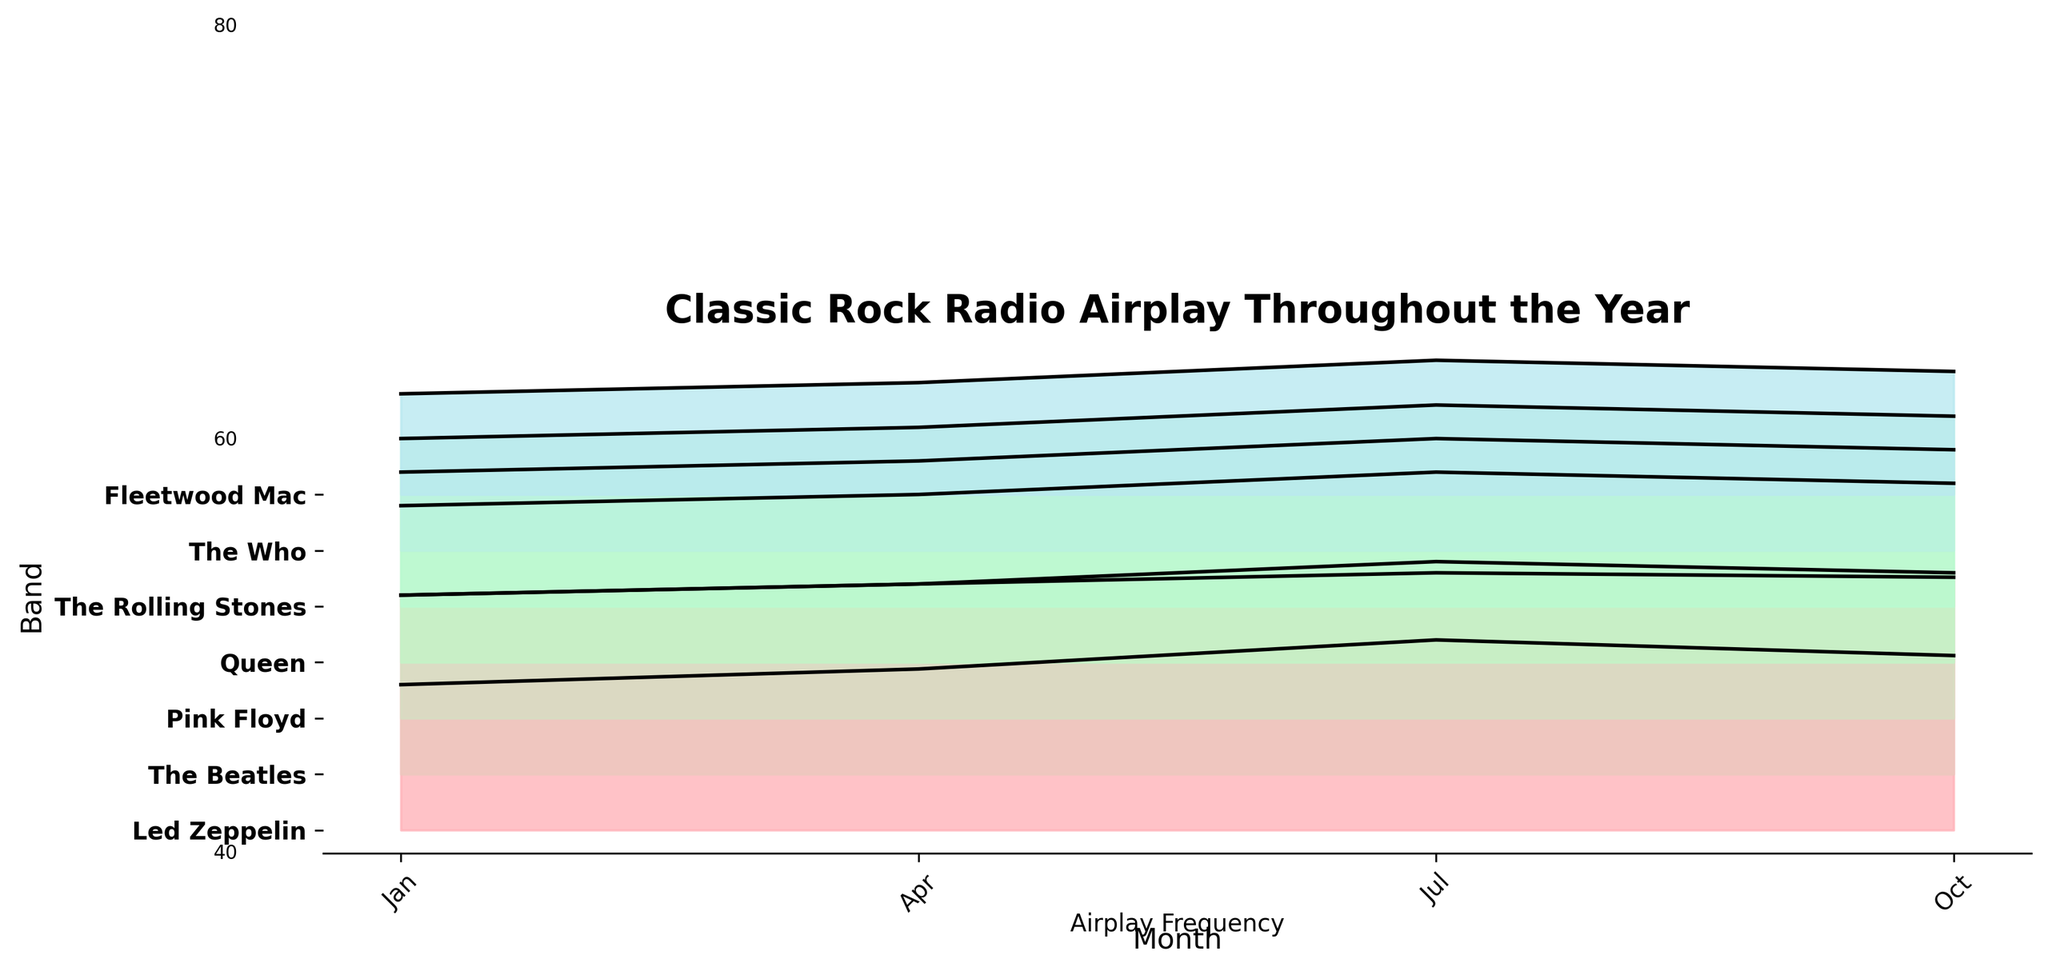What is the title of the plot? The title is located at the top of the plot. It is written in bold and large font to attract attention.
Answer: Classic Rock Radio Airplay Throughout the Year Which band has the highest airplay frequency in July? By examining the ridgeline plot, we can observe the peak points in July. The Beatles have the highest peak in July.
Answer: The Beatles What months are plotted on the x-axis? The x-axis contains the labels for months, plotted in intervals throughout the year. They are listed as Jan, Apr, Jul, and Oct.
Answer: Jan, Apr, Jul, Oct What is the airplay frequency range visible on the y-axis? The y-axis contains visual markers indicating the range of the airplay frequency. Observing the range and intervals, it spans from around 40 to 100.
Answer: 40 to 100 Which band shows the largest increase in airplay frequency from January to July? Compare the frequency values in January and July for each band. The largest increase (from 65 to 85) can be observed for Led Zeppelin, indicating a 20-point rise.
Answer: Led Zeppelin Does any band have a consistent airplay frequency trend throughout the year? A consistent trend would show roughly similar values for each month. Comparing the bands, none have perfectly consistent values, but The Who has the least variation (50, 55, 65, 60).
Answer: The Who How do the airplay frequencies of Fleetwood Mac and Queen compare in January? Look at the ridgeline plot for January. Fleetwood Mac has an airplay frequency of 45, while Queen has a frequency of 70.
Answer: Queen has a higher frequency What is the average airplay frequency for Pink Floyd across all months? Sum the airplay frequencies for Pink Floyd (55 + 60 + 70 + 65), and divide by the number of months (4). The average frequency is (55 + 60 + 70 + 65) / 4 = 62.5.
Answer: 62.5 Who has higher airplay frequency in October, The Rolling Stones or Led Zeppelin? Look at their respective values in October. The Rolling Stones have a value of 70, while Led Zeppelin has 78. Therefore, Led Zeppelin has a higher frequency.
Answer: Led Zeppelin Which bands have a peak airplay frequency equal to or above 85? Identify the bands from the plot that reach or exceed an airplay frequency of 85 at any point. Led Zeppelin (Jul), The Beatles (Jul and Oct), and Queen (Jul) meet this criterion.
Answer: Led Zeppelin, The Beatles, Queen 